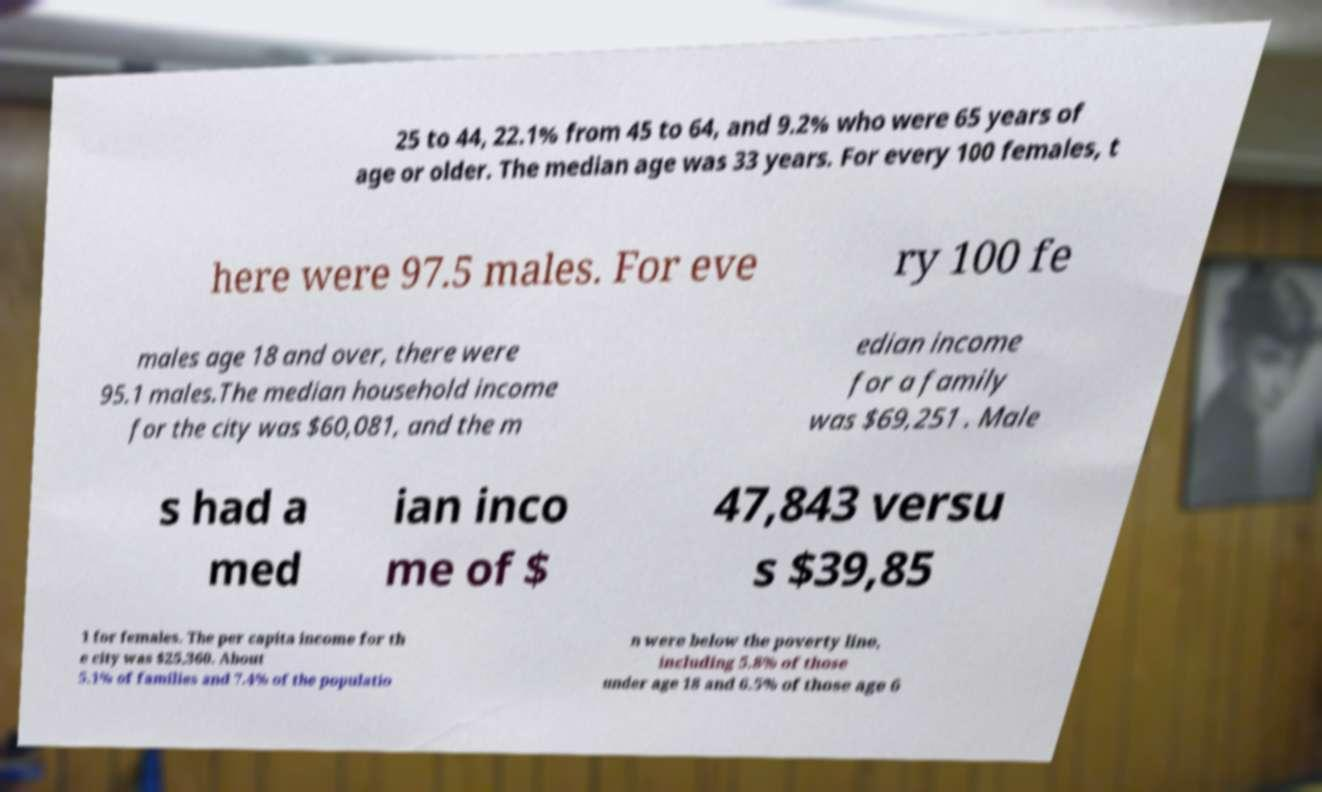There's text embedded in this image that I need extracted. Can you transcribe it verbatim? 25 to 44, 22.1% from 45 to 64, and 9.2% who were 65 years of age or older. The median age was 33 years. For every 100 females, t here were 97.5 males. For eve ry 100 fe males age 18 and over, there were 95.1 males.The median household income for the city was $60,081, and the m edian income for a family was $69,251 . Male s had a med ian inco me of $ 47,843 versu s $39,85 1 for females. The per capita income for th e city was $25,360. About 5.1% of families and 7.4% of the populatio n were below the poverty line, including 5.8% of those under age 18 and 6.5% of those age 6 